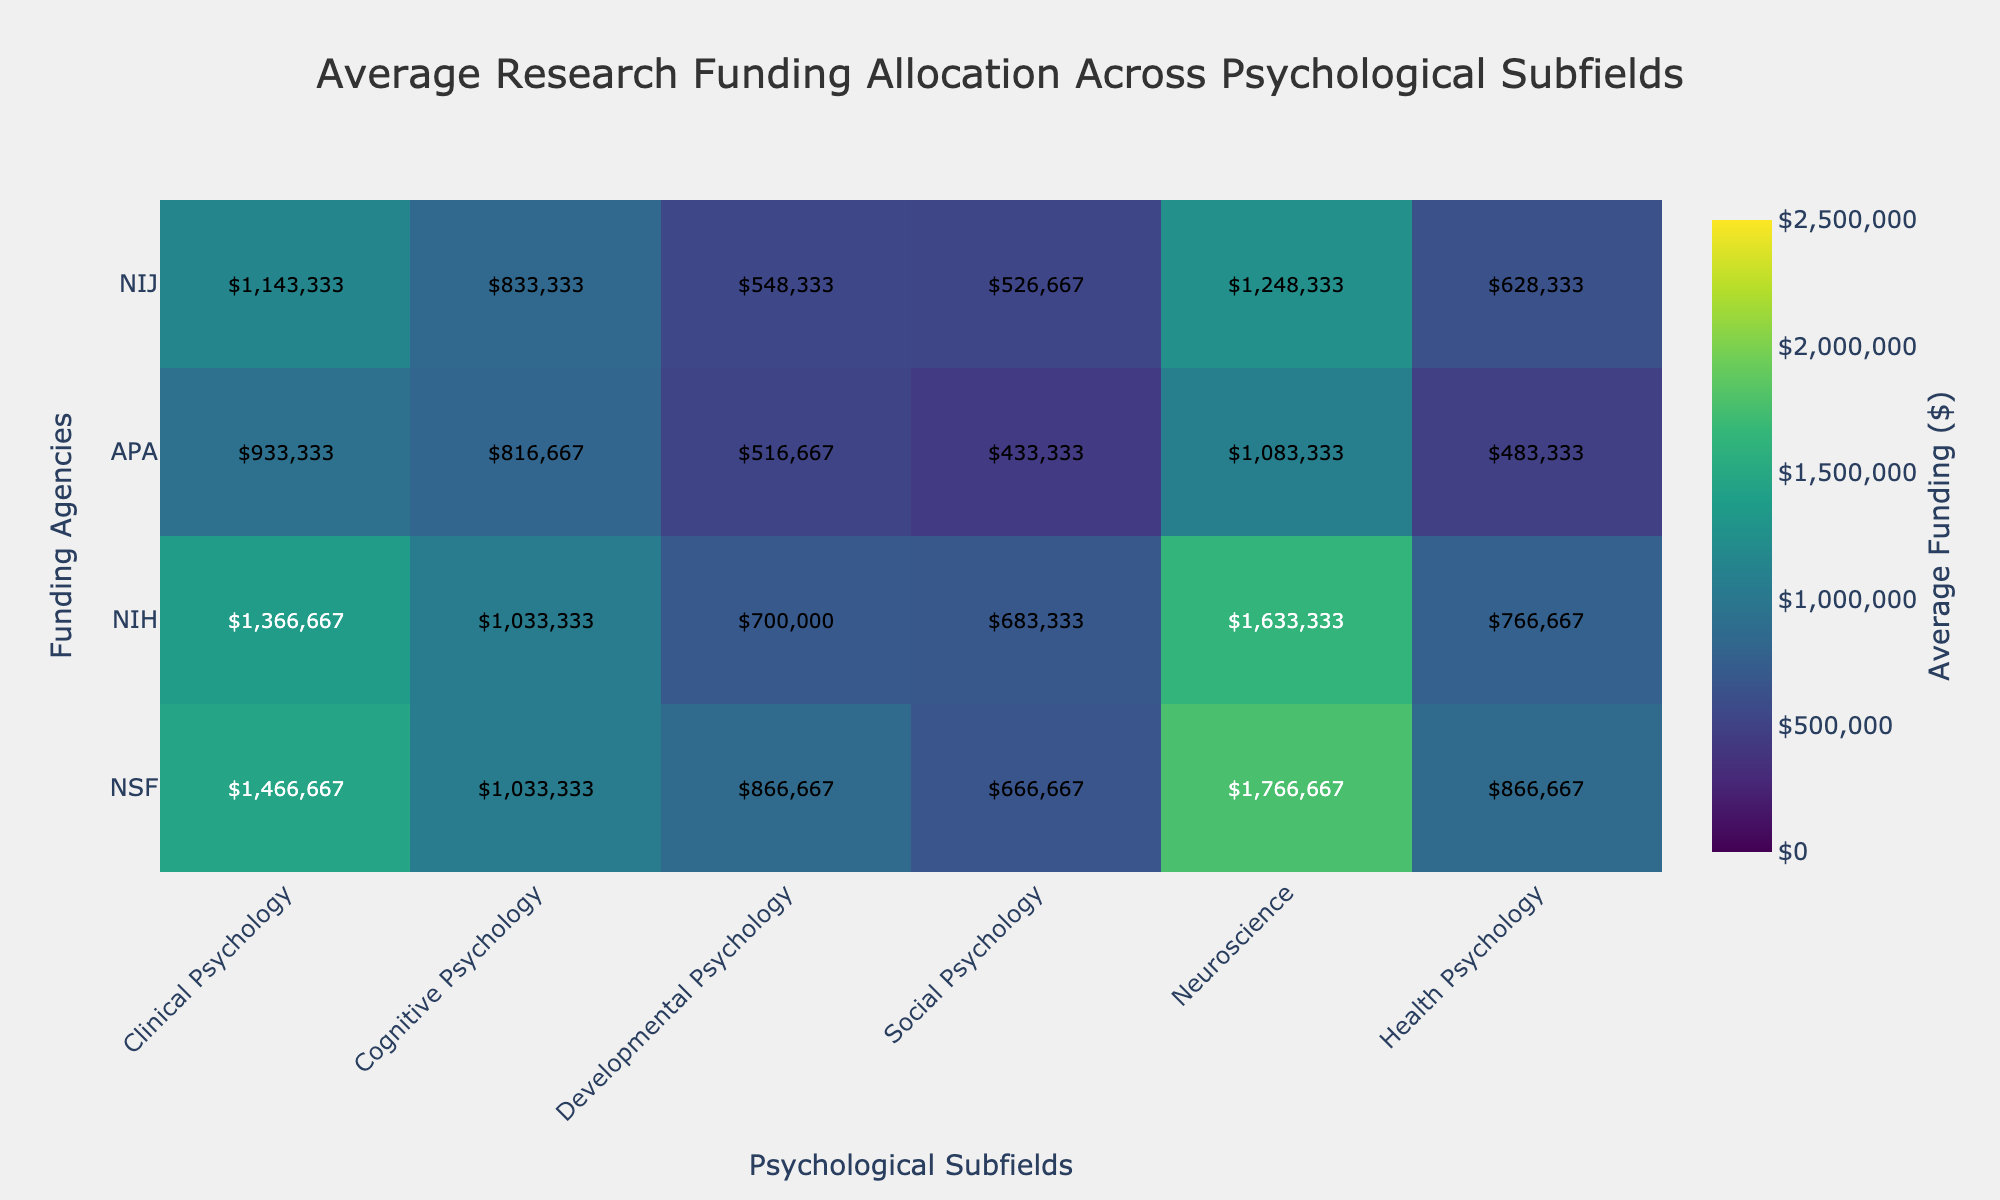What's the title of the heatmap? The title is typically found at the top of the figure, and it provides a summary of what the figure represents.
Answer: Average Research Funding Allocation Across Psychological Subfields How many psychological subfields are represented in the heatmap? The subfields are listed along the x-axis. Counting them gives the total number of subfields represented.
Answer: Six What funding agency allocates the highest average funding for Neuroscience? By examining the color intensity for Neuroscience and comparing them across funding agencies, the agency with the darkest color (highest value) can be identified.
Answer: NIH What's the average funding allocated by NSF for Cognitive Psychology and Social Psychology combined? Identify the average funding values for Cognitive Psychology and Social Psychology under NSF, then sum these values to get the combined amount.
Answer: 825,000 + 1,000,000 = 1,825,000 Which subfield receives the lowest average funding from APA? By observing the heatmap and comparing the values for APA across different subfields, the subfield with the lightest color (lowest value) can be identified.
Answer: Developmental Psychology Compare the average funding for Health Psychology between NSF and NIJ. Which one is higher, and by how much? Identify the average funding values for Health Psychology under NSF and NIJ, then calculate the difference and determine which one is higher.
Answer: NSF: 850,000 and NIJ: 270,000; NSF is higher by 580,000 What is the average funding allocation for Cognitive Psychology across all funding agencies? Sum the average funding values for Cognitive Psychology from all funding agencies, then divide by the number of agencies to get the overall average.
Answer: (1200000 + 1300000 + 600000 + 800000 + 1150000 + 1250000 + 525000 + 725000)/8 = 962,500 How does the average funding for Clinical Psychology from NIH compare to that from NSF? Identify the average funding values for Clinical Psychology from NIH and NSF, then compare them.
Answer: NIH: 2,200,000, NSF: 1,500,000; NIH is higher Which psychological subfield receives the most consistent funding across all agencies? Look for the subfield with the most uniform color intensity across all funding agencies, indicating less variation in funding.
Answer: Health Psychology 